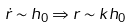<formula> <loc_0><loc_0><loc_500><loc_500>\dot { r } \sim h _ { 0 } \Rightarrow r \sim k h _ { 0 }</formula> 